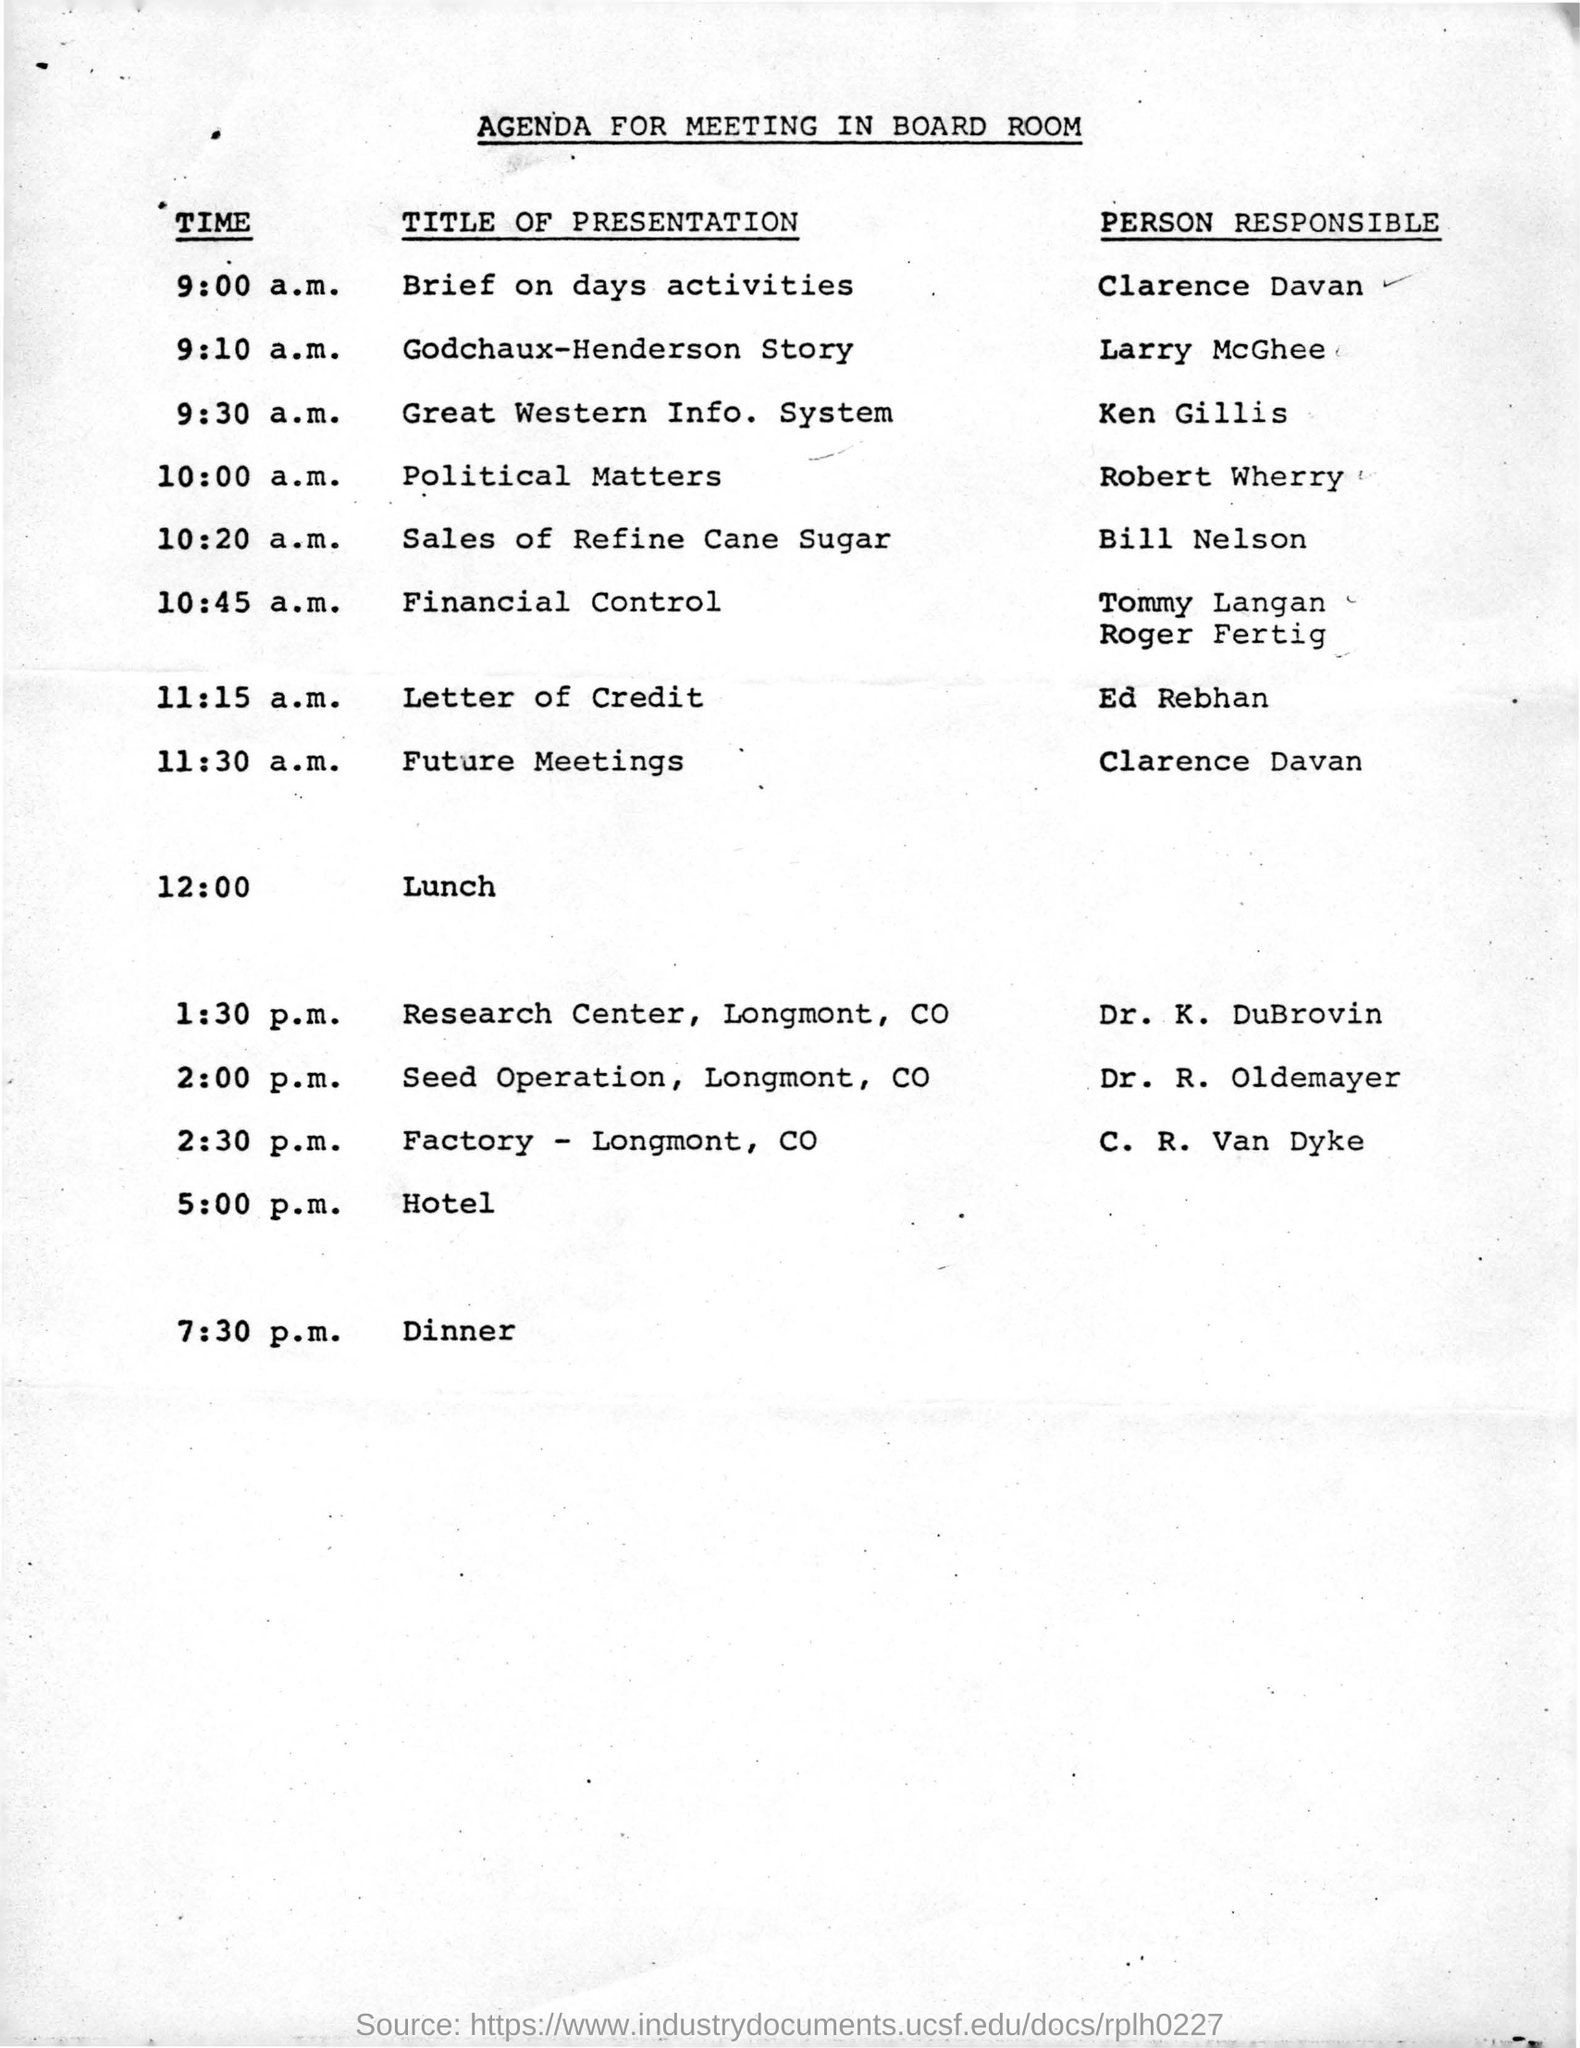List a handful of essential elements in this visual. Clarence Davan will present a brief summary of the day's activities. The presentation that follows lunch is Dr. K. Dubrovin's. The meeting is held in the BOARD ROOM. Larry McGhee is presenting the story of Godchaux-Henderson. The time of Ken Gillis's presentation is 9:30 AM. 